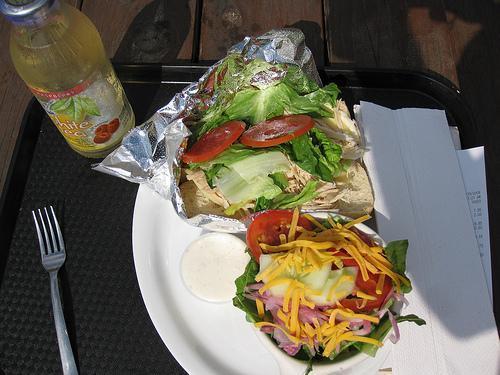How many drinks?
Give a very brief answer. 1. 